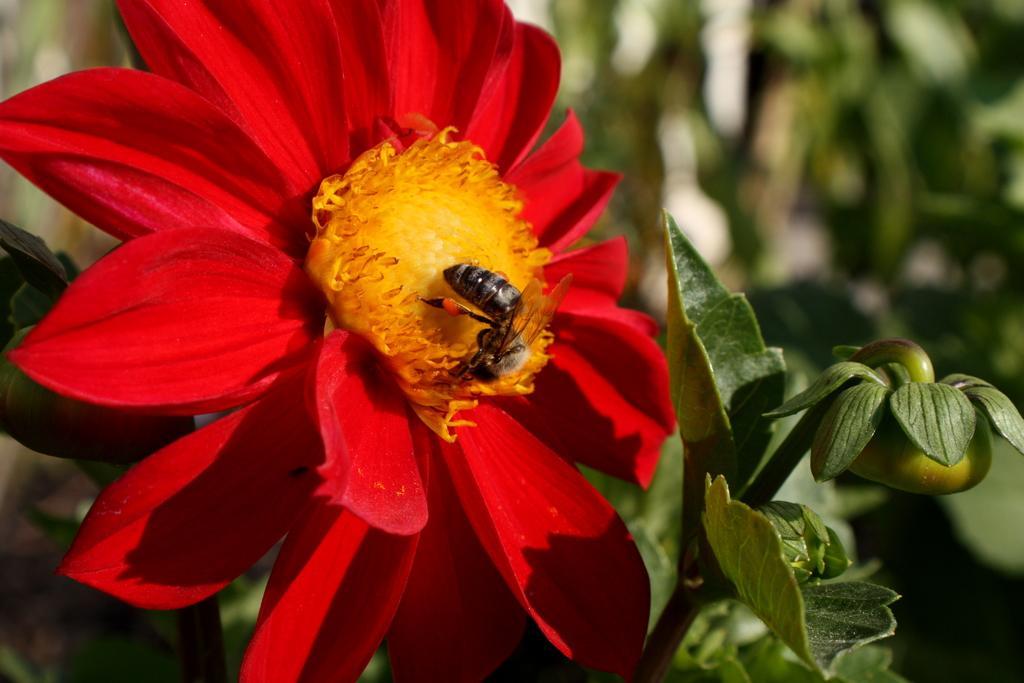Describe this image in one or two sentences. There is a bee on the yellow color part of a red color flower. On the right side, there is a plant having a fruit. And the background is blurred. 